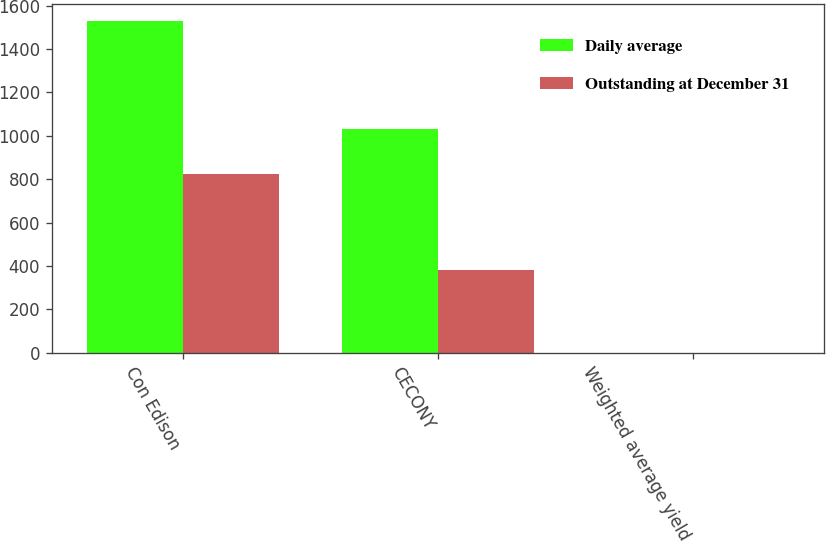Convert chart. <chart><loc_0><loc_0><loc_500><loc_500><stacked_bar_chart><ecel><fcel>Con Edison<fcel>CECONY<fcel>Weighted average yield<nl><fcel>Daily average<fcel>1529<fcel>1033<fcel>0.7<nl><fcel>Outstanding at December 31<fcel>823<fcel>379<fcel>0.4<nl></chart> 